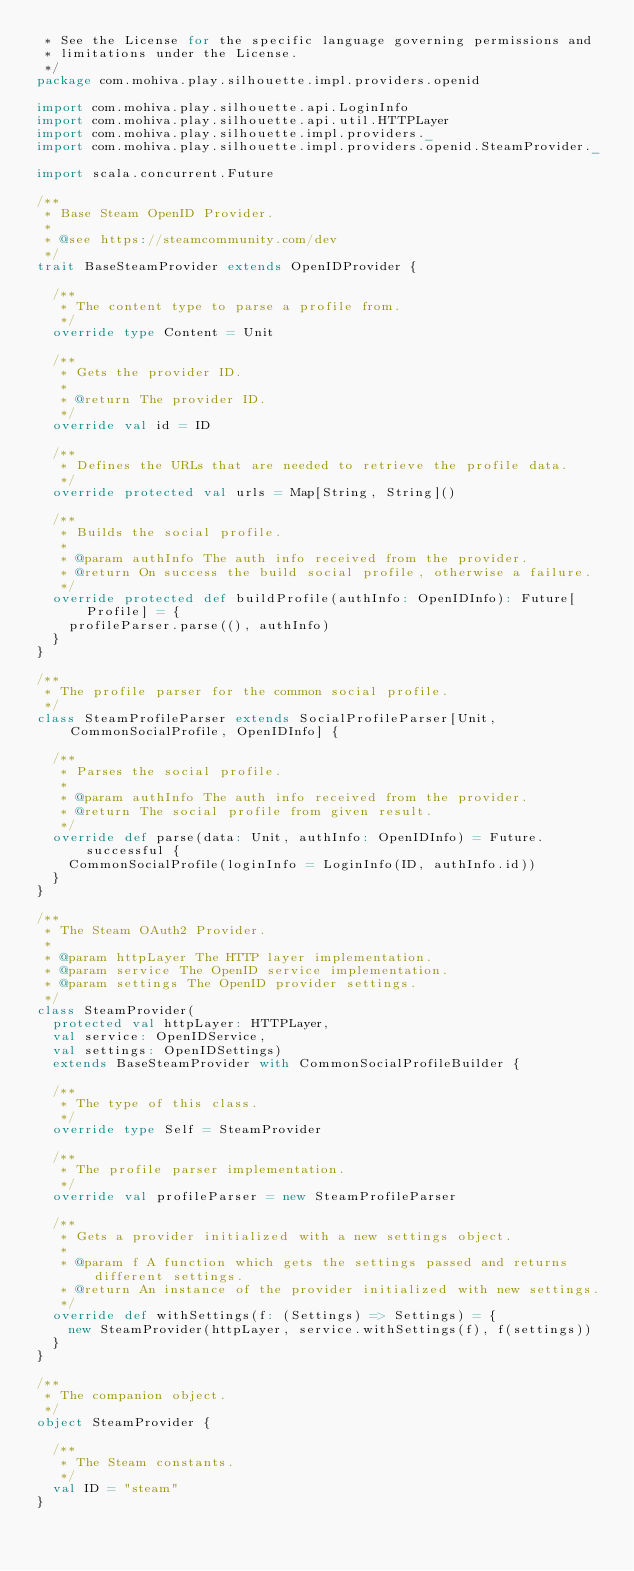<code> <loc_0><loc_0><loc_500><loc_500><_Scala_> * See the License for the specific language governing permissions and
 * limitations under the License.
 */
package com.mohiva.play.silhouette.impl.providers.openid

import com.mohiva.play.silhouette.api.LoginInfo
import com.mohiva.play.silhouette.api.util.HTTPLayer
import com.mohiva.play.silhouette.impl.providers._
import com.mohiva.play.silhouette.impl.providers.openid.SteamProvider._

import scala.concurrent.Future

/**
 * Base Steam OpenID Provider.
 *
 * @see https://steamcommunity.com/dev
 */
trait BaseSteamProvider extends OpenIDProvider {

  /**
   * The content type to parse a profile from.
   */
  override type Content = Unit

  /**
   * Gets the provider ID.
   *
   * @return The provider ID.
   */
  override val id = ID

  /**
   * Defines the URLs that are needed to retrieve the profile data.
   */
  override protected val urls = Map[String, String]()

  /**
   * Builds the social profile.
   *
   * @param authInfo The auth info received from the provider.
   * @return On success the build social profile, otherwise a failure.
   */
  override protected def buildProfile(authInfo: OpenIDInfo): Future[Profile] = {
    profileParser.parse((), authInfo)
  }
}

/**
 * The profile parser for the common social profile.
 */
class SteamProfileParser extends SocialProfileParser[Unit, CommonSocialProfile, OpenIDInfo] {

  /**
   * Parses the social profile.
   *
   * @param authInfo The auth info received from the provider.
   * @return The social profile from given result.
   */
  override def parse(data: Unit, authInfo: OpenIDInfo) = Future.successful {
    CommonSocialProfile(loginInfo = LoginInfo(ID, authInfo.id))
  }
}

/**
 * The Steam OAuth2 Provider.
 *
 * @param httpLayer The HTTP layer implementation.
 * @param service The OpenID service implementation.
 * @param settings The OpenID provider settings.
 */
class SteamProvider(
  protected val httpLayer: HTTPLayer,
  val service: OpenIDService,
  val settings: OpenIDSettings)
  extends BaseSteamProvider with CommonSocialProfileBuilder {

  /**
   * The type of this class.
   */
  override type Self = SteamProvider

  /**
   * The profile parser implementation.
   */
  override val profileParser = new SteamProfileParser

  /**
   * Gets a provider initialized with a new settings object.
   *
   * @param f A function which gets the settings passed and returns different settings.
   * @return An instance of the provider initialized with new settings.
   */
  override def withSettings(f: (Settings) => Settings) = {
    new SteamProvider(httpLayer, service.withSettings(f), f(settings))
  }
}

/**
 * The companion object.
 */
object SteamProvider {

  /**
   * The Steam constants.
   */
  val ID = "steam"
}
</code> 